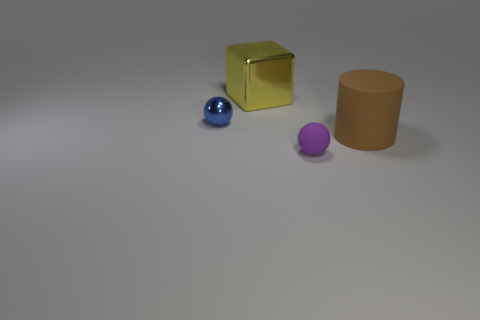What is the material of the object that is both in front of the large shiny thing and behind the big matte object?
Your answer should be compact. Metal. What is the color of the big object that is in front of the tiny sphere behind the big rubber thing?
Keep it short and to the point. Brown. There is a tiny ball that is in front of the brown object; what is it made of?
Provide a short and direct response. Rubber. Is the number of big metallic things less than the number of small spheres?
Your answer should be compact. Yes. There is a tiny blue object; is its shape the same as the big thing that is right of the big yellow shiny cube?
Offer a terse response. No. What is the shape of the object that is both in front of the big metal thing and to the left of the purple matte sphere?
Your response must be concise. Sphere. Are there an equal number of tiny objects to the left of the purple sphere and tiny blue objects on the right side of the brown object?
Ensure brevity in your answer.  No. There is a tiny thing behind the big matte cylinder; is it the same shape as the tiny purple matte object?
Offer a terse response. Yes. What number of purple things are either large rubber objects or spheres?
Your answer should be compact. 1. There is a blue thing that is the same shape as the tiny purple object; what is its material?
Your answer should be very brief. Metal. 